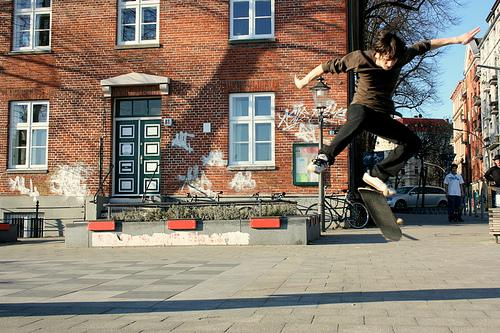Question: who is doing the skateboard trick?
Choices:
A. A man.
B. A girl.
C. A woman.
D. A boy.
Answer with the letter. Answer: D Question: what is the boy doing?
Choices:
A. A skateboard trick.
B. Singing.
C. Laughing.
D. Joking.
Answer with the letter. Answer: A Question: why is the boy in the air?
Choices:
A. He is flying.
B. He is falling.
C. He's doing a trick.
D. He is leaping.
Answer with the letter. Answer: C Question: how many people are skateboarding?
Choices:
A. Two.
B. One.
C. Three.
D. Four.
Answer with the letter. Answer: B 